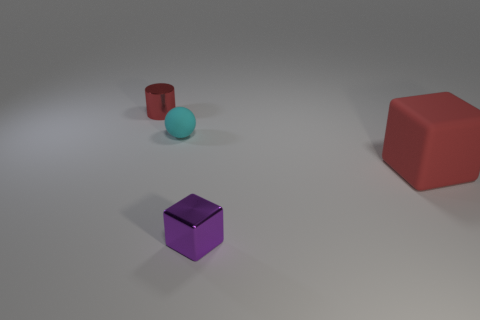Add 3 small cyan metallic cylinders. How many objects exist? 7 Subtract all cylinders. How many objects are left? 3 Add 4 tiny spheres. How many tiny spheres exist? 5 Subtract 0 yellow blocks. How many objects are left? 4 Subtract all shiny balls. Subtract all tiny purple objects. How many objects are left? 3 Add 3 big red things. How many big red things are left? 4 